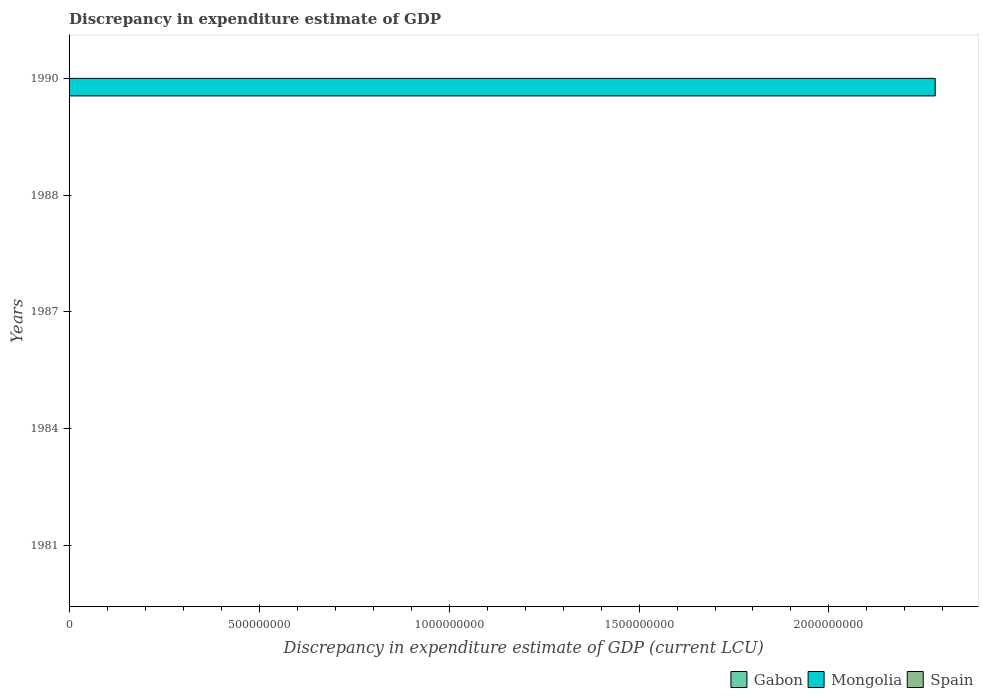Are the number of bars per tick equal to the number of legend labels?
Offer a very short reply. No. Are the number of bars on each tick of the Y-axis equal?
Your answer should be very brief. No. How many bars are there on the 5th tick from the top?
Make the answer very short. 0. What is the label of the 2nd group of bars from the top?
Keep it short and to the point. 1988. In how many cases, is the number of bars for a given year not equal to the number of legend labels?
Offer a terse response. 5. What is the discrepancy in expenditure estimate of GDP in Mongolia in 1987?
Keep it short and to the point. 0. Across all years, what is the maximum discrepancy in expenditure estimate of GDP in Gabon?
Provide a short and direct response. 0. What is the total discrepancy in expenditure estimate of GDP in Mongolia in the graph?
Keep it short and to the point. 2.28e+09. What is the difference between the discrepancy in expenditure estimate of GDP in Gabon in 1984 and that in 1987?
Your response must be concise. 0. What is the difference between the discrepancy in expenditure estimate of GDP in Mongolia in 1990 and the discrepancy in expenditure estimate of GDP in Gabon in 1984?
Ensure brevity in your answer.  2.28e+09. What is the average discrepancy in expenditure estimate of GDP in Gabon per year?
Ensure brevity in your answer.  7e-5. In the year 1990, what is the difference between the discrepancy in expenditure estimate of GDP in Gabon and discrepancy in expenditure estimate of GDP in Mongolia?
Give a very brief answer. -2.28e+09. In how many years, is the discrepancy in expenditure estimate of GDP in Spain greater than 700000000 LCU?
Give a very brief answer. 0. What is the ratio of the discrepancy in expenditure estimate of GDP in Mongolia in 1984 to that in 1990?
Your answer should be very brief. 3.0620551355928905e-5. What is the difference between the highest and the second highest discrepancy in expenditure estimate of GDP in Gabon?
Your answer should be very brief. 8e-5. Is the sum of the discrepancy in expenditure estimate of GDP in Gabon in 1984 and 1987 greater than the maximum discrepancy in expenditure estimate of GDP in Mongolia across all years?
Your answer should be very brief. No. Are all the bars in the graph horizontal?
Provide a succinct answer. Yes. How many years are there in the graph?
Your answer should be compact. 5. What is the difference between two consecutive major ticks on the X-axis?
Provide a short and direct response. 5.00e+08. Are the values on the major ticks of X-axis written in scientific E-notation?
Offer a terse response. No. How are the legend labels stacked?
Make the answer very short. Horizontal. What is the title of the graph?
Give a very brief answer. Discrepancy in expenditure estimate of GDP. Does "Czech Republic" appear as one of the legend labels in the graph?
Your response must be concise. No. What is the label or title of the X-axis?
Make the answer very short. Discrepancy in expenditure estimate of GDP (current LCU). What is the label or title of the Y-axis?
Make the answer very short. Years. What is the Discrepancy in expenditure estimate of GDP (current LCU) of Gabon in 1984?
Ensure brevity in your answer.  0. What is the Discrepancy in expenditure estimate of GDP (current LCU) in Mongolia in 1984?
Your response must be concise. 6.98e+04. What is the Discrepancy in expenditure estimate of GDP (current LCU) in Gabon in 1987?
Offer a terse response. 3e-5. What is the Discrepancy in expenditure estimate of GDP (current LCU) of Mongolia in 1987?
Give a very brief answer. 0. What is the Discrepancy in expenditure estimate of GDP (current LCU) in Spain in 1987?
Offer a very short reply. 0. What is the Discrepancy in expenditure estimate of GDP (current LCU) in Gabon in 1988?
Provide a succinct answer. 0. What is the Discrepancy in expenditure estimate of GDP (current LCU) of Spain in 1988?
Your answer should be very brief. 0. What is the Discrepancy in expenditure estimate of GDP (current LCU) in Gabon in 1990?
Your response must be concise. 0. What is the Discrepancy in expenditure estimate of GDP (current LCU) in Mongolia in 1990?
Make the answer very short. 2.28e+09. Across all years, what is the maximum Discrepancy in expenditure estimate of GDP (current LCU) of Mongolia?
Ensure brevity in your answer.  2.28e+09. What is the total Discrepancy in expenditure estimate of GDP (current LCU) of Gabon in the graph?
Make the answer very short. 0. What is the total Discrepancy in expenditure estimate of GDP (current LCU) in Mongolia in the graph?
Your answer should be very brief. 2.28e+09. What is the total Discrepancy in expenditure estimate of GDP (current LCU) of Spain in the graph?
Offer a very short reply. 0. What is the difference between the Discrepancy in expenditure estimate of GDP (current LCU) of Gabon in 1984 and that in 1987?
Your response must be concise. 0. What is the difference between the Discrepancy in expenditure estimate of GDP (current LCU) of Gabon in 1984 and that in 1990?
Your response must be concise. 0. What is the difference between the Discrepancy in expenditure estimate of GDP (current LCU) of Mongolia in 1984 and that in 1990?
Your answer should be compact. -2.28e+09. What is the difference between the Discrepancy in expenditure estimate of GDP (current LCU) of Gabon in 1987 and that in 1990?
Make the answer very short. -0. What is the difference between the Discrepancy in expenditure estimate of GDP (current LCU) of Gabon in 1984 and the Discrepancy in expenditure estimate of GDP (current LCU) of Mongolia in 1990?
Your response must be concise. -2.28e+09. What is the difference between the Discrepancy in expenditure estimate of GDP (current LCU) in Gabon in 1987 and the Discrepancy in expenditure estimate of GDP (current LCU) in Mongolia in 1990?
Offer a terse response. -2.28e+09. What is the average Discrepancy in expenditure estimate of GDP (current LCU) in Gabon per year?
Ensure brevity in your answer.  0. What is the average Discrepancy in expenditure estimate of GDP (current LCU) in Mongolia per year?
Provide a short and direct response. 4.56e+08. What is the average Discrepancy in expenditure estimate of GDP (current LCU) of Spain per year?
Offer a terse response. 0. In the year 1984, what is the difference between the Discrepancy in expenditure estimate of GDP (current LCU) of Gabon and Discrepancy in expenditure estimate of GDP (current LCU) of Mongolia?
Keep it short and to the point. -6.98e+04. In the year 1990, what is the difference between the Discrepancy in expenditure estimate of GDP (current LCU) in Gabon and Discrepancy in expenditure estimate of GDP (current LCU) in Mongolia?
Offer a very short reply. -2.28e+09. What is the ratio of the Discrepancy in expenditure estimate of GDP (current LCU) in Gabon in 1984 to that in 1987?
Your answer should be compact. 6.67. What is the ratio of the Discrepancy in expenditure estimate of GDP (current LCU) of Gabon in 1984 to that in 1990?
Keep it short and to the point. 1.67. What is the ratio of the Discrepancy in expenditure estimate of GDP (current LCU) of Gabon in 1987 to that in 1990?
Keep it short and to the point. 0.25. What is the difference between the highest and the lowest Discrepancy in expenditure estimate of GDP (current LCU) of Mongolia?
Make the answer very short. 2.28e+09. 